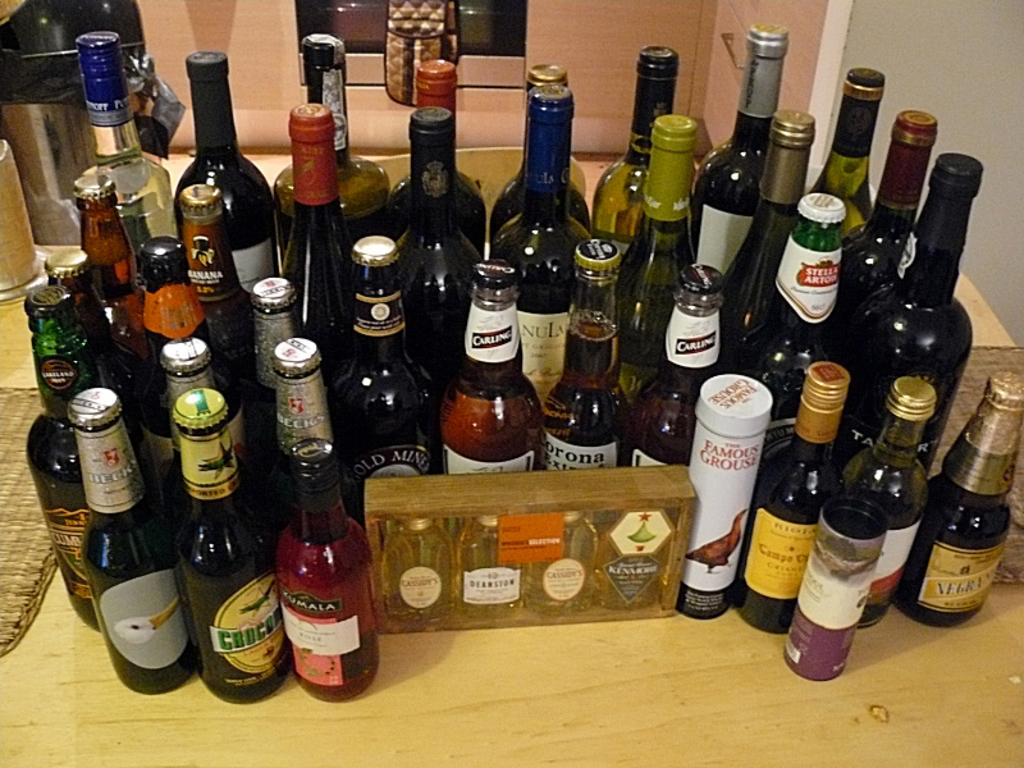<image>
Present a compact description of the photo's key features. A bunch of beer and wine bottles on a table with a Beck's beer bottle on the far left. 